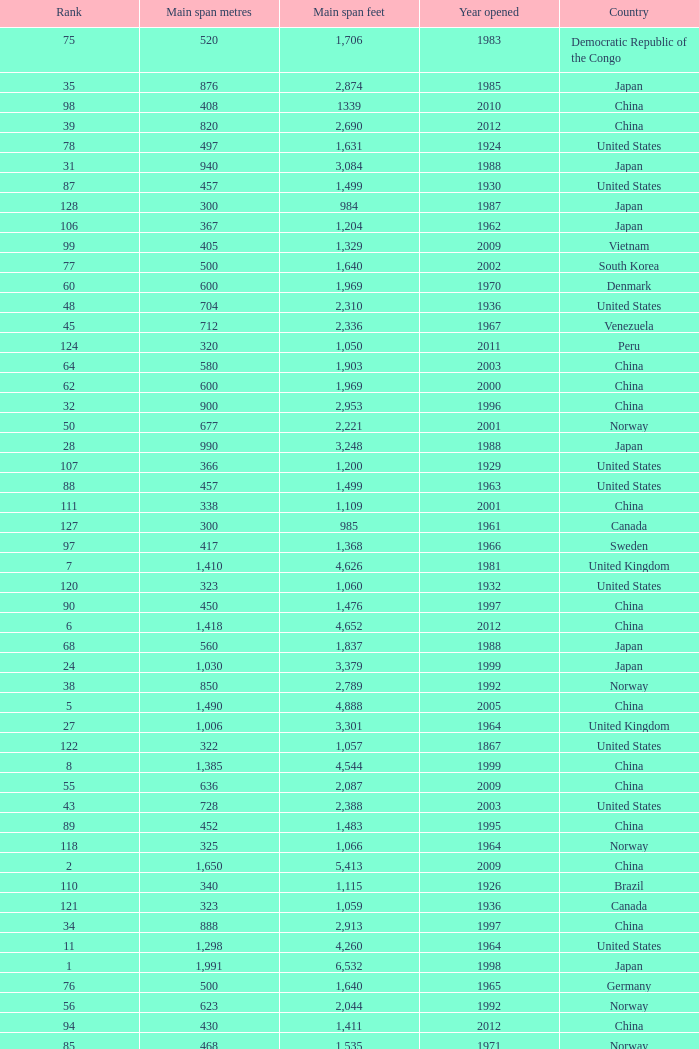What is the main span in feet from a year of 2009 or more recent with a rank less than 94 and 1,310 main span metres? 4298.0. 